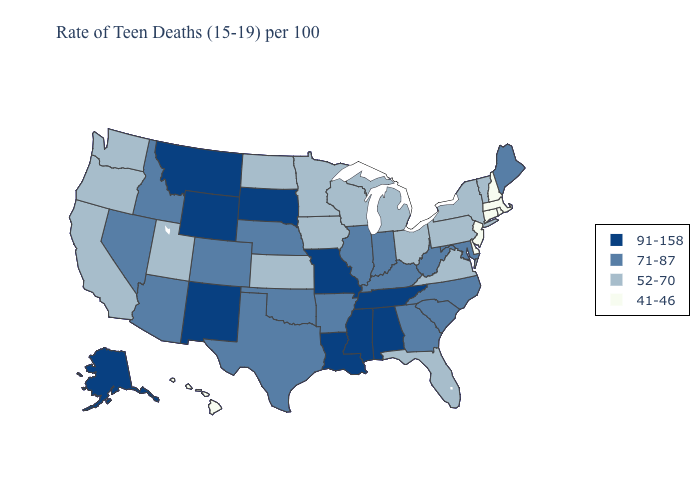What is the highest value in the USA?
Short answer required. 91-158. What is the value of Connecticut?
Quick response, please. 41-46. Name the states that have a value in the range 71-87?
Keep it brief. Arizona, Arkansas, Colorado, Georgia, Idaho, Illinois, Indiana, Kentucky, Maine, Maryland, Nebraska, Nevada, North Carolina, Oklahoma, South Carolina, Texas, West Virginia. Does Oklahoma have the highest value in the USA?
Answer briefly. No. Does the first symbol in the legend represent the smallest category?
Concise answer only. No. What is the value of Georgia?
Be succinct. 71-87. Which states have the lowest value in the South?
Write a very short answer. Delaware. Does Tennessee have the highest value in the South?
Be succinct. Yes. What is the value of Ohio?
Keep it brief. 52-70. Name the states that have a value in the range 41-46?
Answer briefly. Connecticut, Delaware, Hawaii, Massachusetts, New Hampshire, New Jersey, Rhode Island. Does South Dakota have the same value as South Carolina?
Write a very short answer. No. Which states have the lowest value in the West?
Concise answer only. Hawaii. What is the lowest value in states that border New Mexico?
Short answer required. 52-70. What is the value of Texas?
Answer briefly. 71-87. Does Connecticut have the same value as Montana?
Answer briefly. No. 